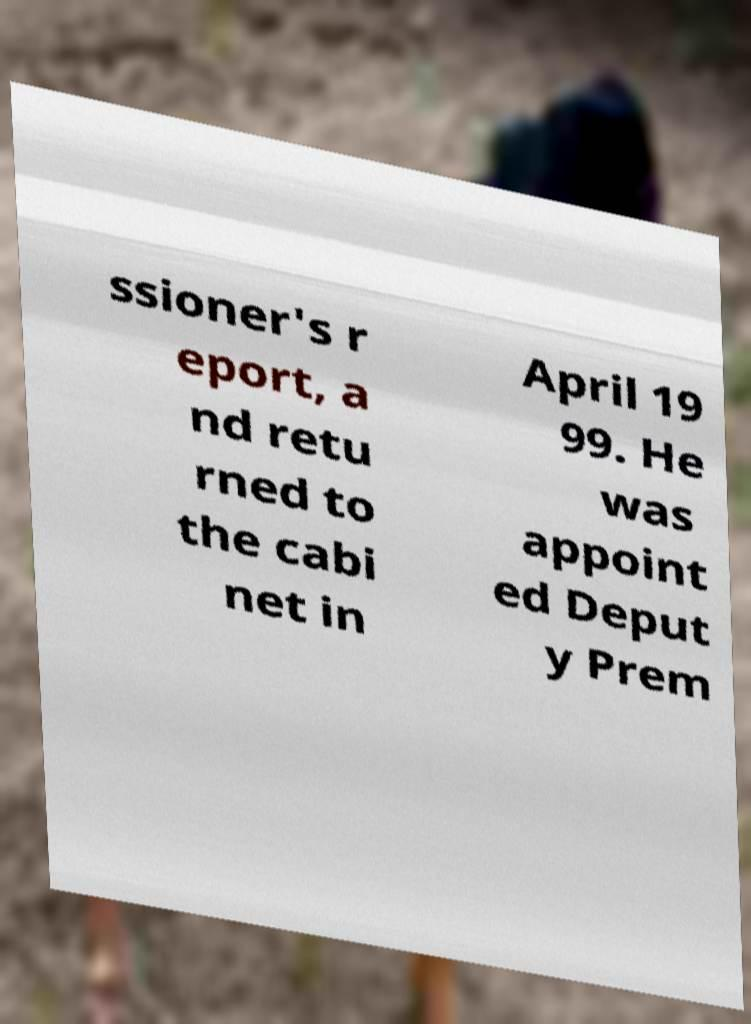What messages or text are displayed in this image? I need them in a readable, typed format. ssioner's r eport, a nd retu rned to the cabi net in April 19 99. He was appoint ed Deput y Prem 